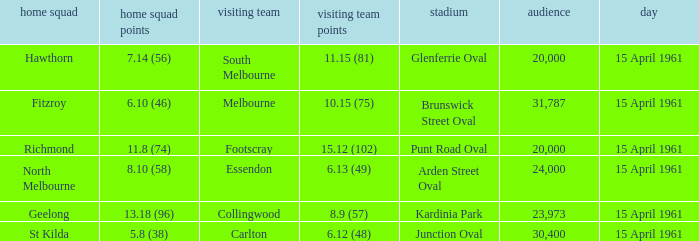Which venue had a home team score of 6.10 (46)? Brunswick Street Oval. 